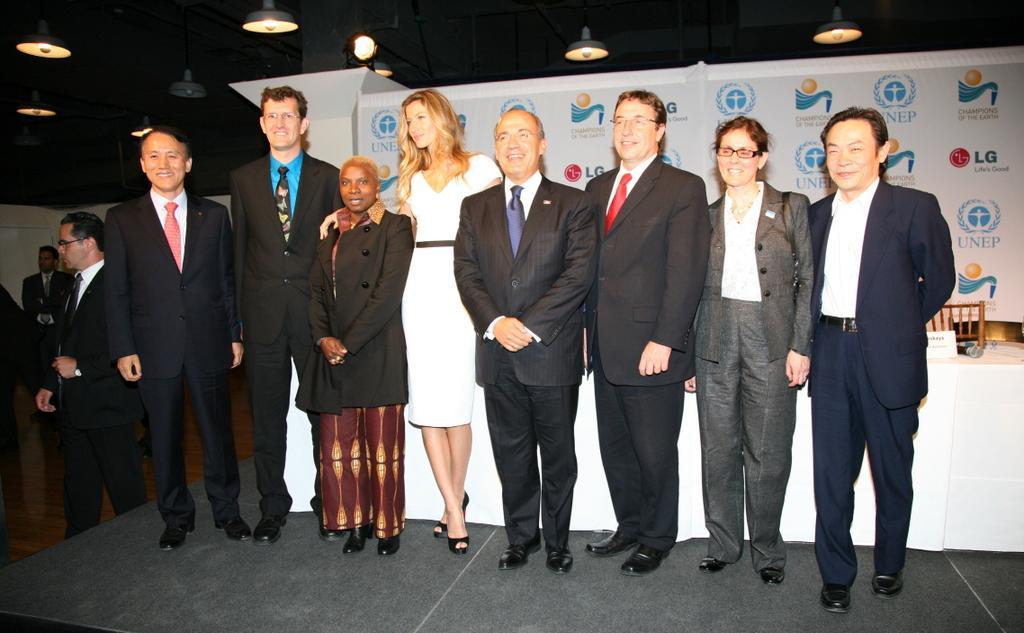Describe this image in one or two sentences. Here we can see few persons. This is floor and there are lights. In the background we can see a table, cloth, chair, and a banner. 